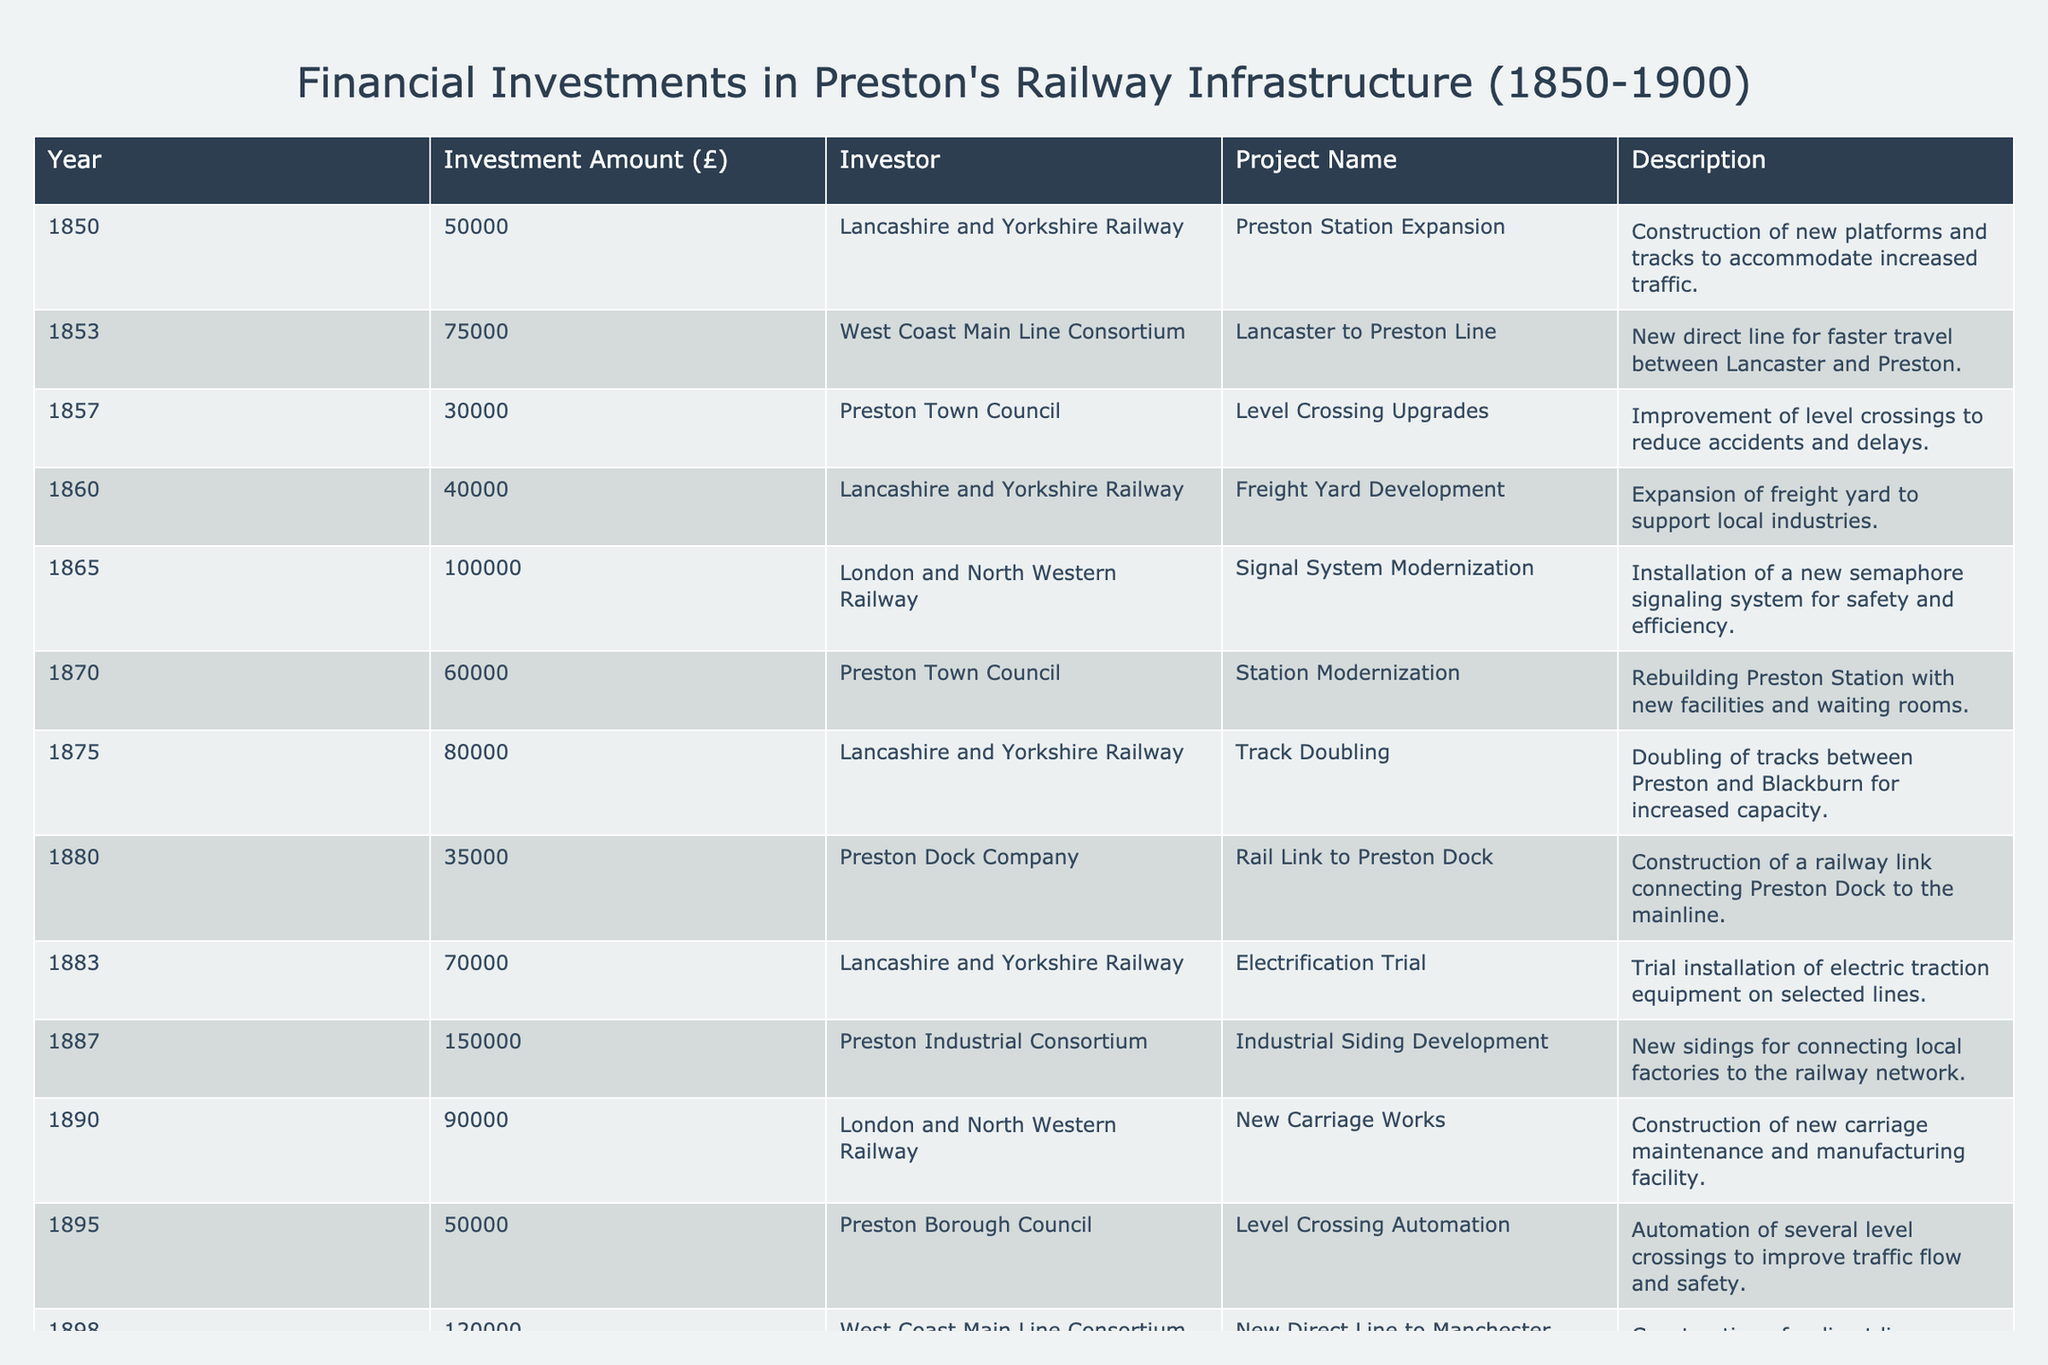What was the total investment amount made by the Lancashire and Yorkshire Railway? To find this, I will look for all rows where the investor is "Lancashire and Yorkshire Railway" and sum their investment amounts. The investments are £50,000 (1850), £40,000 (1860), £80,000 (1875), and £70,000 (1883), which equals £50,000 + £40,000 + £80,000 + £70,000 = £240,000.
Answer: £240,000 Which year saw the largest single investment in Preston's railway infrastructure? I will check each investment amount in the table to identify the highest value. The largest investment recorded is £150,000 in the year 1887 for the Preston Industrial Consortium project.
Answer: 1887 Did the Preston Town Council invest in railway infrastructure more than once? I will count the entries for "Preston Town Council" in the investor column. There are two entries: one in 1857 for level crossing upgrades and another in 1870 for station modernization. Therefore, the answer is yes.
Answer: Yes What was the average investment amount for the projects carried out by the West Coast Main Line Consortium? First, identify the investment amounts associated with the West Coast Main Line Consortium. They are £75,000 (1853) and £120,000 (1898). I sum these amounts: £75,000 + £120,000 = £195,000. Then, divide this total by the number of investments (2) to get the average: £195,000 / 2 = £97,500.
Answer: £97,500 How many projects were completed between the years 1850 and 1870? I will count all the entries from the table where the year is between 1850 and 1870, inclusive. The relevant years are 1850, 1853, 1857, 1860, 1865, and 1870, totaling 6 projects.
Answer: 6 Was there any investment made for electrification of railway lines prior to 1883? Checking the project names in the table for an electrification attempt before 1883, I find that the electrification trial project is the first, occurring in 1883, confirming that no earlier investments for electrification were made.
Answer: No Which project received the investment of £100,000? I will look for the investment of £100,000 in the investment amount column. This amount corresponds to the signal system modernization project in 1865.
Answer: Signal System Modernization What was the total investment amount from the Preston Borough Council for the two projects? First, I will identify the investment amounts from the Preston Borough Council. They invested £50,000 for level crossing automation in 1895. There is only one project listed, so the total investment remains £50,000.
Answer: £50,000 